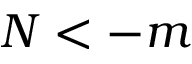<formula> <loc_0><loc_0><loc_500><loc_500>N < - m</formula> 